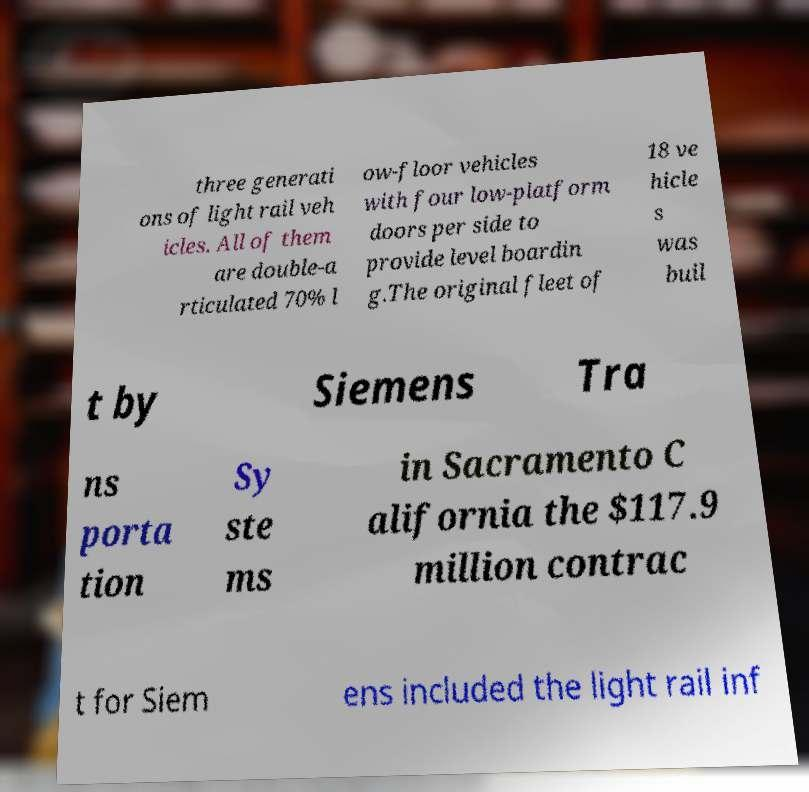I need the written content from this picture converted into text. Can you do that? three generati ons of light rail veh icles. All of them are double-a rticulated 70% l ow-floor vehicles with four low-platform doors per side to provide level boardin g.The original fleet of 18 ve hicle s was buil t by Siemens Tra ns porta tion Sy ste ms in Sacramento C alifornia the $117.9 million contrac t for Siem ens included the light rail inf 